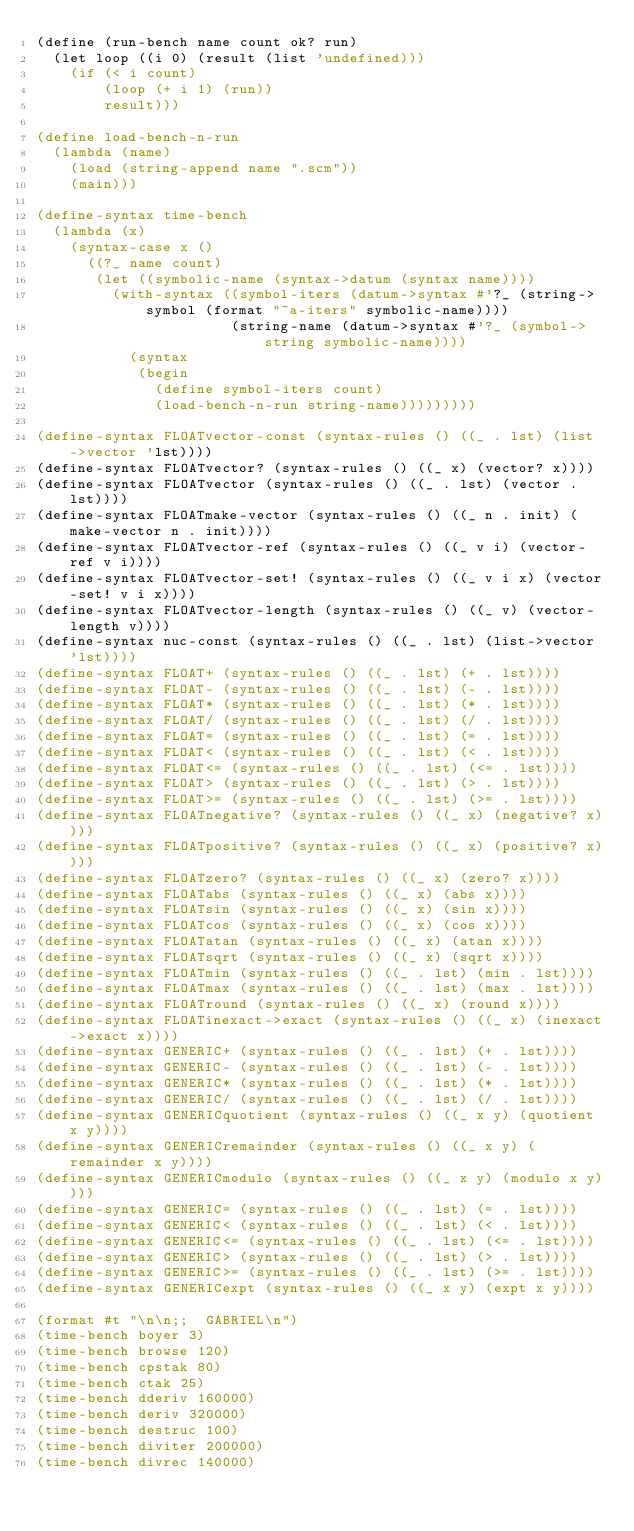Convert code to text. <code><loc_0><loc_0><loc_500><loc_500><_Scheme_>(define (run-bench name count ok? run)
  (let loop ((i 0) (result (list 'undefined)))
    (if (< i count)
        (loop (+ i 1) (run))
        result)))

(define load-bench-n-run
  (lambda (name)
    (load (string-append name ".scm"))
    (main)))

(define-syntax time-bench
  (lambda (x)
    (syntax-case x ()
      ((?_ name count)
       (let ((symbolic-name (syntax->datum (syntax name))))
         (with-syntax ((symbol-iters (datum->syntax #'?_ (string->symbol (format "~a-iters" symbolic-name))))
                       (string-name (datum->syntax #'?_ (symbol->string symbolic-name))))
           (syntax
            (begin
              (define symbol-iters count)
              (load-bench-n-run string-name)))))))))

(define-syntax FLOATvector-const (syntax-rules () ((_ . lst) (list->vector 'lst))))
(define-syntax FLOATvector? (syntax-rules () ((_ x) (vector? x))))
(define-syntax FLOATvector (syntax-rules () ((_ . lst) (vector . lst))))
(define-syntax FLOATmake-vector (syntax-rules () ((_ n . init) (make-vector n . init))))
(define-syntax FLOATvector-ref (syntax-rules () ((_ v i) (vector-ref v i))))
(define-syntax FLOATvector-set! (syntax-rules () ((_ v i x) (vector-set! v i x))))
(define-syntax FLOATvector-length (syntax-rules () ((_ v) (vector-length v))))
(define-syntax nuc-const (syntax-rules () ((_ . lst) (list->vector 'lst))))
(define-syntax FLOAT+ (syntax-rules () ((_ . lst) (+ . lst))))
(define-syntax FLOAT- (syntax-rules () ((_ . lst) (- . lst))))
(define-syntax FLOAT* (syntax-rules () ((_ . lst) (* . lst))))
(define-syntax FLOAT/ (syntax-rules () ((_ . lst) (/ . lst))))
(define-syntax FLOAT= (syntax-rules () ((_ . lst) (= . lst))))
(define-syntax FLOAT< (syntax-rules () ((_ . lst) (< . lst))))
(define-syntax FLOAT<= (syntax-rules () ((_ . lst) (<= . lst))))
(define-syntax FLOAT> (syntax-rules () ((_ . lst) (> . lst))))
(define-syntax FLOAT>= (syntax-rules () ((_ . lst) (>= . lst))))
(define-syntax FLOATnegative? (syntax-rules () ((_ x) (negative? x))))
(define-syntax FLOATpositive? (syntax-rules () ((_ x) (positive? x))))
(define-syntax FLOATzero? (syntax-rules () ((_ x) (zero? x))))
(define-syntax FLOATabs (syntax-rules () ((_ x) (abs x))))
(define-syntax FLOATsin (syntax-rules () ((_ x) (sin x))))
(define-syntax FLOATcos (syntax-rules () ((_ x) (cos x))))
(define-syntax FLOATatan (syntax-rules () ((_ x) (atan x))))
(define-syntax FLOATsqrt (syntax-rules () ((_ x) (sqrt x))))
(define-syntax FLOATmin (syntax-rules () ((_ . lst) (min . lst))))
(define-syntax FLOATmax (syntax-rules () ((_ . lst) (max . lst))))
(define-syntax FLOATround (syntax-rules () ((_ x) (round x))))
(define-syntax FLOATinexact->exact (syntax-rules () ((_ x) (inexact->exact x))))
(define-syntax GENERIC+ (syntax-rules () ((_ . lst) (+ . lst))))
(define-syntax GENERIC- (syntax-rules () ((_ . lst) (- . lst))))
(define-syntax GENERIC* (syntax-rules () ((_ . lst) (* . lst))))
(define-syntax GENERIC/ (syntax-rules () ((_ . lst) (/ . lst))))
(define-syntax GENERICquotient (syntax-rules () ((_ x y) (quotient x y))))
(define-syntax GENERICremainder (syntax-rules () ((_ x y) (remainder x y))))
(define-syntax GENERICmodulo (syntax-rules () ((_ x y) (modulo x y))))
(define-syntax GENERIC= (syntax-rules () ((_ . lst) (= . lst))))
(define-syntax GENERIC< (syntax-rules () ((_ . lst) (< . lst))))
(define-syntax GENERIC<= (syntax-rules () ((_ . lst) (<= . lst))))
(define-syntax GENERIC> (syntax-rules () ((_ . lst) (> . lst))))
(define-syntax GENERIC>= (syntax-rules () ((_ . lst) (>= . lst))))
(define-syntax GENERICexpt (syntax-rules () ((_ x y) (expt x y))))

(format #t "\n\n;;  GABRIEL\n")
(time-bench boyer 3)
(time-bench browse 120)
(time-bench cpstak 80)
(time-bench ctak 25)
(time-bench dderiv 160000)
(time-bench deriv 320000)
(time-bench destruc 100)
(time-bench diviter 200000)
(time-bench divrec 140000)</code> 